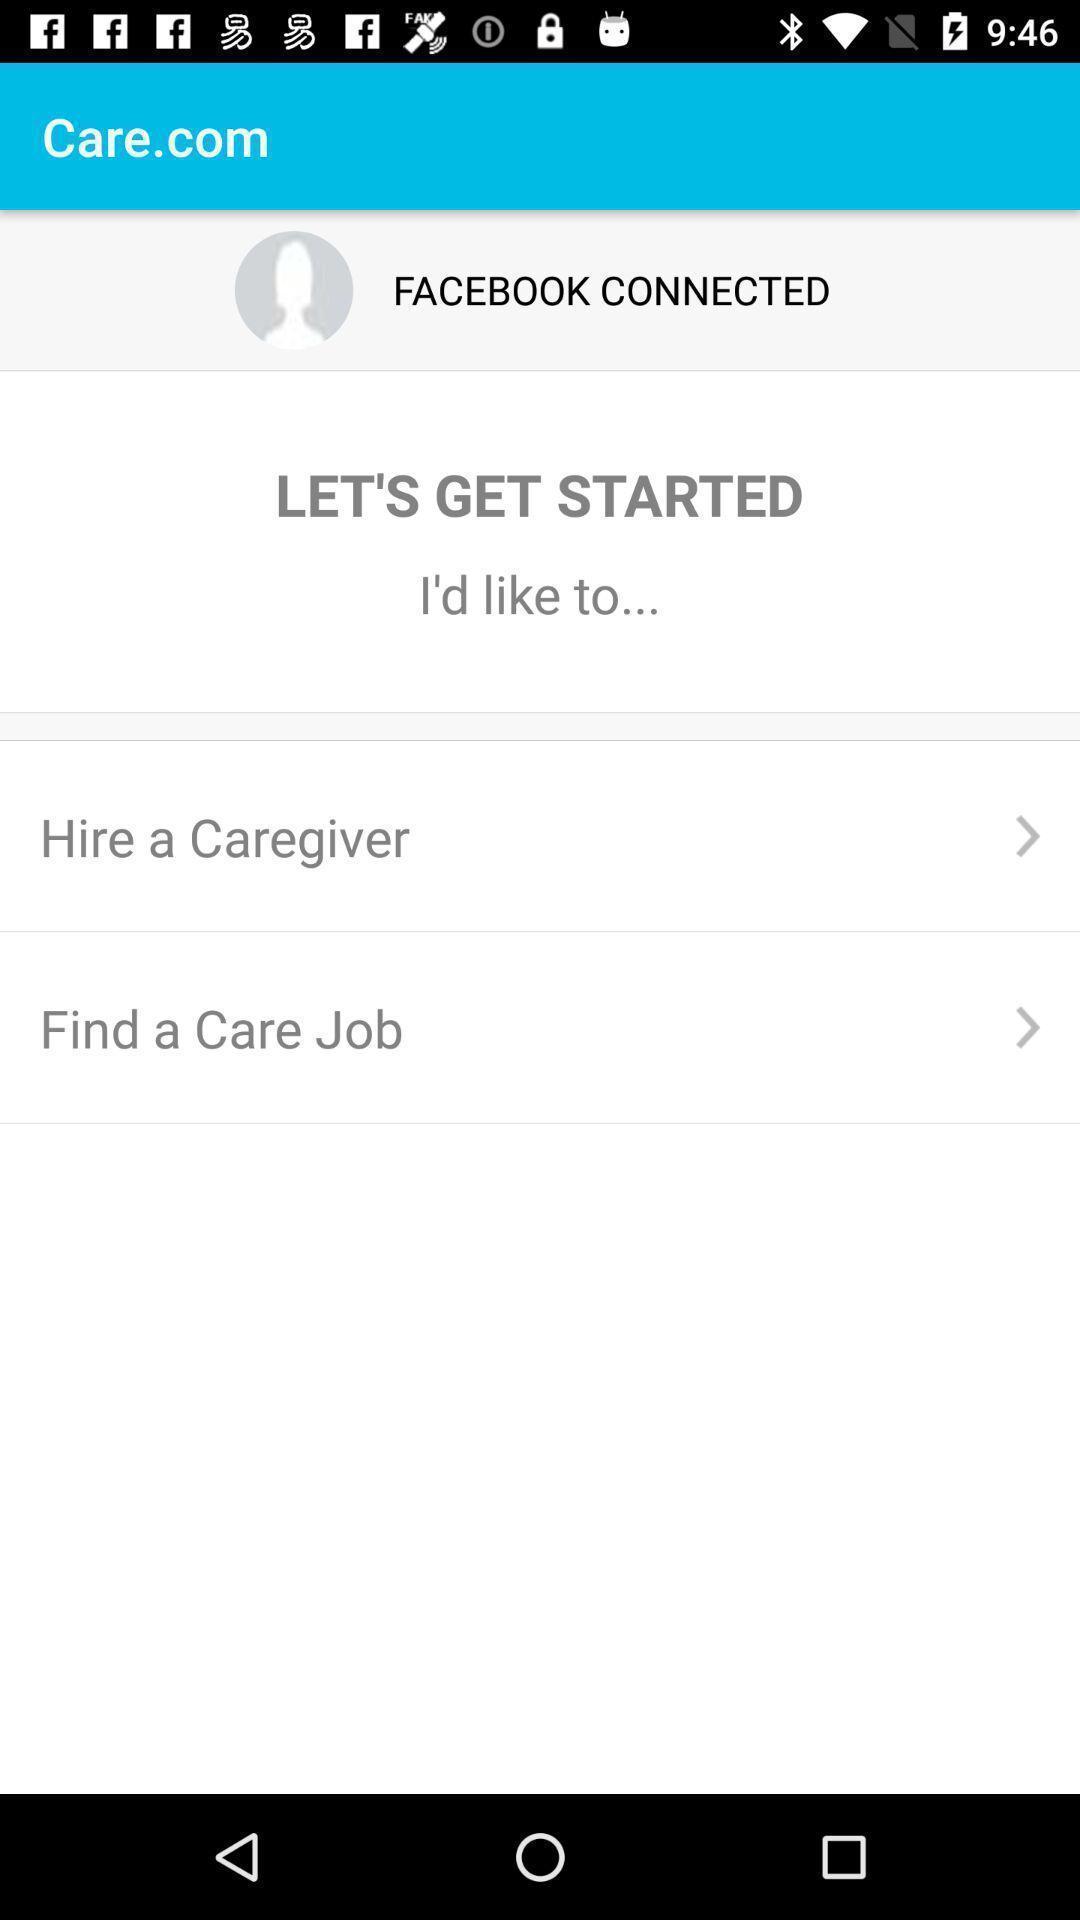Tell me what you see in this picture. Welcome page. 